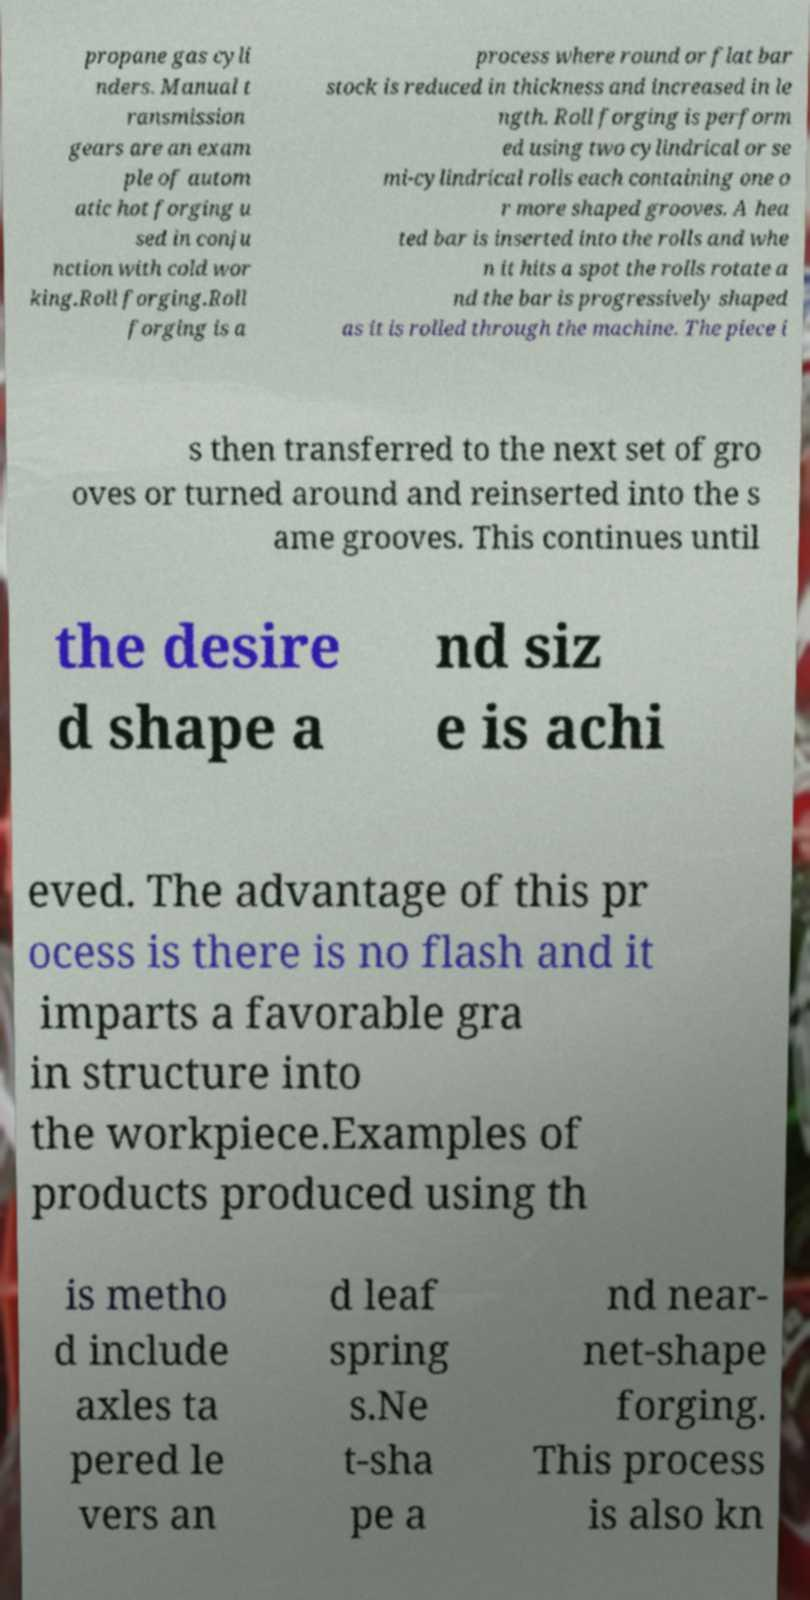Can you read and provide the text displayed in the image?This photo seems to have some interesting text. Can you extract and type it out for me? propane gas cyli nders. Manual t ransmission gears are an exam ple of autom atic hot forging u sed in conju nction with cold wor king.Roll forging.Roll forging is a process where round or flat bar stock is reduced in thickness and increased in le ngth. Roll forging is perform ed using two cylindrical or se mi-cylindrical rolls each containing one o r more shaped grooves. A hea ted bar is inserted into the rolls and whe n it hits a spot the rolls rotate a nd the bar is progressively shaped as it is rolled through the machine. The piece i s then transferred to the next set of gro oves or turned around and reinserted into the s ame grooves. This continues until the desire d shape a nd siz e is achi eved. The advantage of this pr ocess is there is no flash and it imparts a favorable gra in structure into the workpiece.Examples of products produced using th is metho d include axles ta pered le vers an d leaf spring s.Ne t-sha pe a nd near- net-shape forging. This process is also kn 